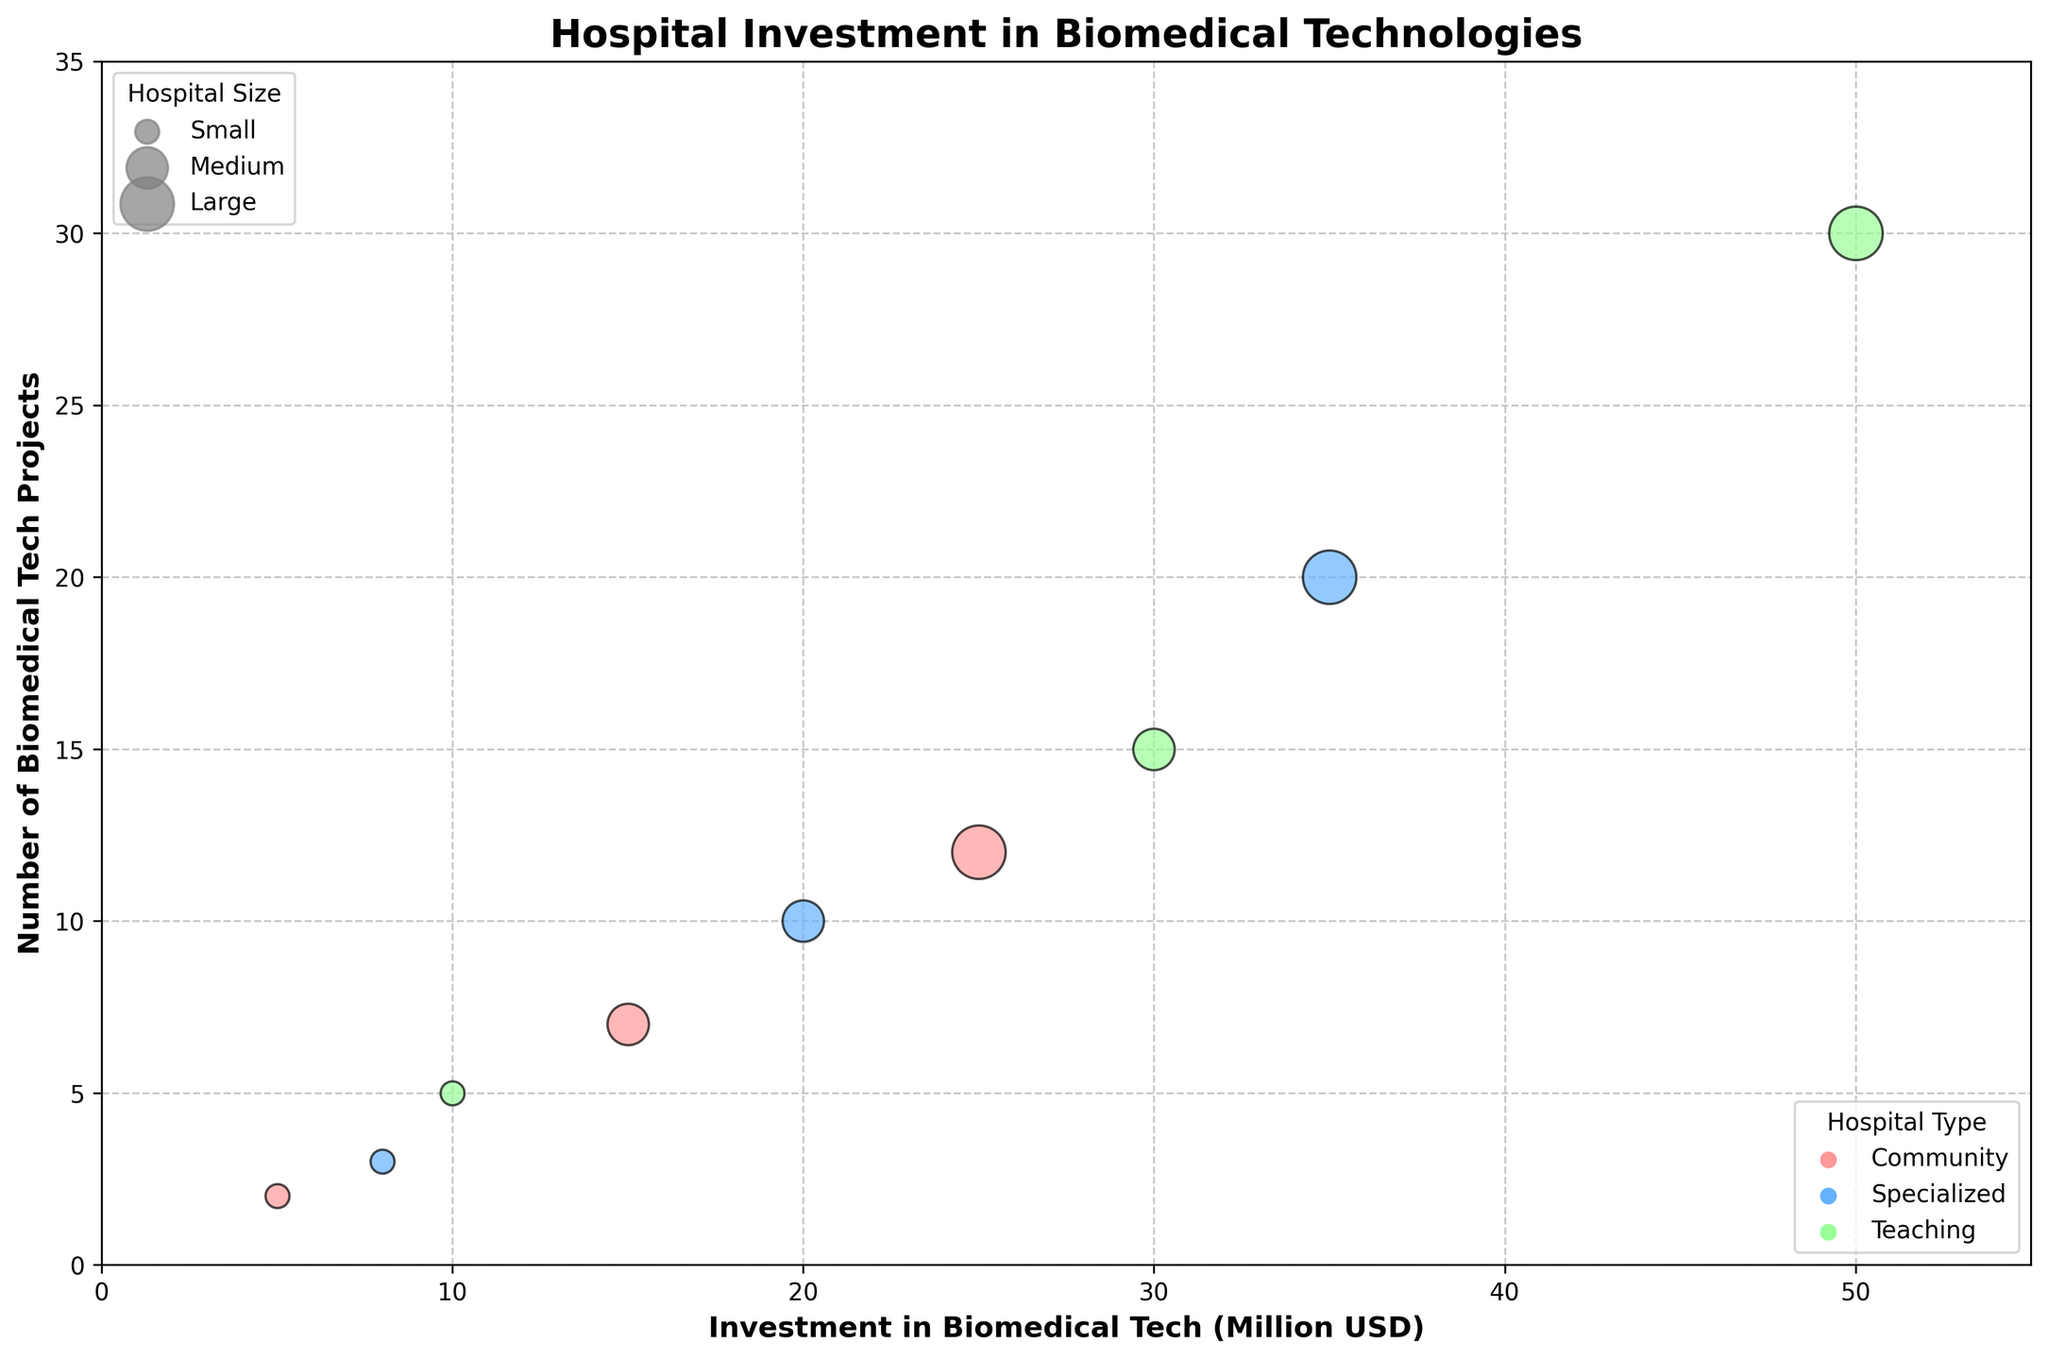How many data points are in the figure? The figure contains one data point for each combination of hospital size and type. Since there are 3 sizes (Small, Medium, Large) and 3 types (Community, Specialized, Teaching), there are 3 x 3 = 9 data points in total.
Answer: 9 What are the x-axis and y-axis labels? The x-axis label is 'Investment in Biomedical Tech (Million USD)' and the y-axis label is 'Number of Biomedical Tech Projects'.
Answer: Investment in Biomedical Tech (Million USD), Number of Biomedical Tech Projects Which type of hospital has the highest investment in biomedical tech? We look at the x-axis to find the hospital type with the largest x-coordinate. The hospital type with the highest x-coordinate is 'Teaching' with an investment of 50 million USD.
Answer: Teaching Between medium and large specialized hospitals, which has more biomedical tech projects? By comparing the y-coordinates for Medium Specialized and Large Specialized hospitals, we see that Large Specialized hospitals have their y-coordinate at 20, while Medium Specialized has their y-coordinate at 10. Thus, Large Specialized hospitals have more projects.
Answer: Large Specialized What is the bubble size for small Community hospitals? The bubble size corresponds to hospital size, with Small represented by the smallest bubble. From the code, Small hospitals have a size of 100.
Answer: 100 Which category and size combination has the maximum number of biomedical tech projects? By examining the y-coordinates of all bubbles, the bubble with the highest y-coordinate is the Large Teaching hospital with 30 projects.
Answer: Large Teaching What is the total investment for medium-sized hospitals? Summing the x-coordinates for all medium-sized hospitals: Community (15 million USD), Specialized (20 million USD), Teaching (30 million USD). 15 + 20 + 30 = 65 million USD.
Answer: 65 million USD Compare the number of biomedical tech projects between small and medium teaching hospitals. Small Teaching hospitals have a y-coordinate of 5, while Medium Teaching hospitals have 15. So Medium Teaching hospitals have 10 more projects than Small Teaching.
Answer: Medium Teaching, 10 more If we combine the investments of all community hospitals, what would be the total investment? Summing the x-coordinates for all Community hospitals: Small (5 million USD), Medium (15 million USD), Large (25 million USD). 5 + 15 + 25 = 45 million USD.
Answer: 45 million USD How does the investment in biomedical tech vary amongst different sizes for the Specialized hospital type? Examining the x-coordinates for Specialized hospitals: Small (8 million USD), Medium (20 million USD), Large (35 million USD). The investment increases with hospital size.
Answer: It increases with size 